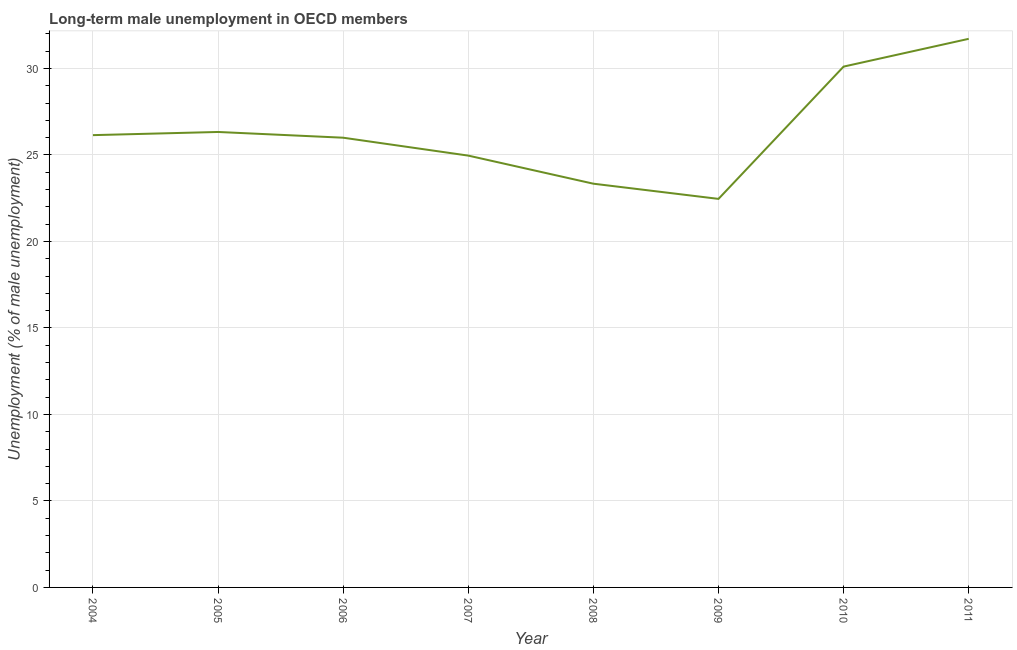What is the long-term male unemployment in 2004?
Offer a terse response. 26.15. Across all years, what is the maximum long-term male unemployment?
Give a very brief answer. 31.72. Across all years, what is the minimum long-term male unemployment?
Provide a short and direct response. 22.46. In which year was the long-term male unemployment minimum?
Offer a terse response. 2009. What is the sum of the long-term male unemployment?
Keep it short and to the point. 211.07. What is the difference between the long-term male unemployment in 2006 and 2011?
Give a very brief answer. -5.72. What is the average long-term male unemployment per year?
Offer a very short reply. 26.38. What is the median long-term male unemployment?
Give a very brief answer. 26.07. Do a majority of the years between 2006 and 2007 (inclusive) have long-term male unemployment greater than 9 %?
Ensure brevity in your answer.  Yes. What is the ratio of the long-term male unemployment in 2006 to that in 2011?
Provide a short and direct response. 0.82. Is the difference between the long-term male unemployment in 2004 and 2009 greater than the difference between any two years?
Make the answer very short. No. What is the difference between the highest and the second highest long-term male unemployment?
Keep it short and to the point. 1.61. What is the difference between the highest and the lowest long-term male unemployment?
Offer a very short reply. 9.25. Does the long-term male unemployment monotonically increase over the years?
Provide a succinct answer. No. How many lines are there?
Your answer should be compact. 1. What is the difference between two consecutive major ticks on the Y-axis?
Your response must be concise. 5. Does the graph contain any zero values?
Ensure brevity in your answer.  No. Does the graph contain grids?
Your response must be concise. Yes. What is the title of the graph?
Make the answer very short. Long-term male unemployment in OECD members. What is the label or title of the X-axis?
Provide a succinct answer. Year. What is the label or title of the Y-axis?
Keep it short and to the point. Unemployment (% of male unemployment). What is the Unemployment (% of male unemployment) in 2004?
Provide a succinct answer. 26.15. What is the Unemployment (% of male unemployment) in 2005?
Ensure brevity in your answer.  26.33. What is the Unemployment (% of male unemployment) of 2006?
Ensure brevity in your answer.  26. What is the Unemployment (% of male unemployment) of 2007?
Provide a succinct answer. 24.96. What is the Unemployment (% of male unemployment) in 2008?
Make the answer very short. 23.34. What is the Unemployment (% of male unemployment) in 2009?
Give a very brief answer. 22.46. What is the Unemployment (% of male unemployment) of 2010?
Your response must be concise. 30.11. What is the Unemployment (% of male unemployment) in 2011?
Your answer should be very brief. 31.72. What is the difference between the Unemployment (% of male unemployment) in 2004 and 2005?
Make the answer very short. -0.18. What is the difference between the Unemployment (% of male unemployment) in 2004 and 2006?
Your answer should be compact. 0.15. What is the difference between the Unemployment (% of male unemployment) in 2004 and 2007?
Your answer should be very brief. 1.18. What is the difference between the Unemployment (% of male unemployment) in 2004 and 2008?
Provide a short and direct response. 2.81. What is the difference between the Unemployment (% of male unemployment) in 2004 and 2009?
Your answer should be very brief. 3.69. What is the difference between the Unemployment (% of male unemployment) in 2004 and 2010?
Offer a very short reply. -3.96. What is the difference between the Unemployment (% of male unemployment) in 2004 and 2011?
Your answer should be very brief. -5.57. What is the difference between the Unemployment (% of male unemployment) in 2005 and 2006?
Your answer should be very brief. 0.33. What is the difference between the Unemployment (% of male unemployment) in 2005 and 2007?
Ensure brevity in your answer.  1.37. What is the difference between the Unemployment (% of male unemployment) in 2005 and 2008?
Give a very brief answer. 2.99. What is the difference between the Unemployment (% of male unemployment) in 2005 and 2009?
Make the answer very short. 3.87. What is the difference between the Unemployment (% of male unemployment) in 2005 and 2010?
Ensure brevity in your answer.  -3.78. What is the difference between the Unemployment (% of male unemployment) in 2005 and 2011?
Give a very brief answer. -5.38. What is the difference between the Unemployment (% of male unemployment) in 2006 and 2007?
Make the answer very short. 1.04. What is the difference between the Unemployment (% of male unemployment) in 2006 and 2008?
Give a very brief answer. 2.66. What is the difference between the Unemployment (% of male unemployment) in 2006 and 2009?
Offer a terse response. 3.54. What is the difference between the Unemployment (% of male unemployment) in 2006 and 2010?
Make the answer very short. -4.11. What is the difference between the Unemployment (% of male unemployment) in 2006 and 2011?
Ensure brevity in your answer.  -5.72. What is the difference between the Unemployment (% of male unemployment) in 2007 and 2008?
Your response must be concise. 1.62. What is the difference between the Unemployment (% of male unemployment) in 2007 and 2009?
Your answer should be very brief. 2.5. What is the difference between the Unemployment (% of male unemployment) in 2007 and 2010?
Provide a succinct answer. -5.15. What is the difference between the Unemployment (% of male unemployment) in 2007 and 2011?
Provide a short and direct response. -6.75. What is the difference between the Unemployment (% of male unemployment) in 2008 and 2009?
Give a very brief answer. 0.88. What is the difference between the Unemployment (% of male unemployment) in 2008 and 2010?
Give a very brief answer. -6.77. What is the difference between the Unemployment (% of male unemployment) in 2008 and 2011?
Your answer should be very brief. -8.38. What is the difference between the Unemployment (% of male unemployment) in 2009 and 2010?
Your response must be concise. -7.65. What is the difference between the Unemployment (% of male unemployment) in 2009 and 2011?
Make the answer very short. -9.25. What is the difference between the Unemployment (% of male unemployment) in 2010 and 2011?
Make the answer very short. -1.61. What is the ratio of the Unemployment (% of male unemployment) in 2004 to that in 2006?
Give a very brief answer. 1.01. What is the ratio of the Unemployment (% of male unemployment) in 2004 to that in 2007?
Your answer should be compact. 1.05. What is the ratio of the Unemployment (% of male unemployment) in 2004 to that in 2008?
Make the answer very short. 1.12. What is the ratio of the Unemployment (% of male unemployment) in 2004 to that in 2009?
Provide a short and direct response. 1.16. What is the ratio of the Unemployment (% of male unemployment) in 2004 to that in 2010?
Give a very brief answer. 0.87. What is the ratio of the Unemployment (% of male unemployment) in 2004 to that in 2011?
Give a very brief answer. 0.82. What is the ratio of the Unemployment (% of male unemployment) in 2005 to that in 2007?
Your response must be concise. 1.05. What is the ratio of the Unemployment (% of male unemployment) in 2005 to that in 2008?
Keep it short and to the point. 1.13. What is the ratio of the Unemployment (% of male unemployment) in 2005 to that in 2009?
Provide a short and direct response. 1.17. What is the ratio of the Unemployment (% of male unemployment) in 2005 to that in 2010?
Your answer should be very brief. 0.87. What is the ratio of the Unemployment (% of male unemployment) in 2005 to that in 2011?
Your response must be concise. 0.83. What is the ratio of the Unemployment (% of male unemployment) in 2006 to that in 2007?
Provide a short and direct response. 1.04. What is the ratio of the Unemployment (% of male unemployment) in 2006 to that in 2008?
Your response must be concise. 1.11. What is the ratio of the Unemployment (% of male unemployment) in 2006 to that in 2009?
Your answer should be very brief. 1.16. What is the ratio of the Unemployment (% of male unemployment) in 2006 to that in 2010?
Give a very brief answer. 0.86. What is the ratio of the Unemployment (% of male unemployment) in 2006 to that in 2011?
Keep it short and to the point. 0.82. What is the ratio of the Unemployment (% of male unemployment) in 2007 to that in 2008?
Make the answer very short. 1.07. What is the ratio of the Unemployment (% of male unemployment) in 2007 to that in 2009?
Provide a short and direct response. 1.11. What is the ratio of the Unemployment (% of male unemployment) in 2007 to that in 2010?
Make the answer very short. 0.83. What is the ratio of the Unemployment (% of male unemployment) in 2007 to that in 2011?
Your answer should be very brief. 0.79. What is the ratio of the Unemployment (% of male unemployment) in 2008 to that in 2009?
Your answer should be very brief. 1.04. What is the ratio of the Unemployment (% of male unemployment) in 2008 to that in 2010?
Your response must be concise. 0.78. What is the ratio of the Unemployment (% of male unemployment) in 2008 to that in 2011?
Offer a very short reply. 0.74. What is the ratio of the Unemployment (% of male unemployment) in 2009 to that in 2010?
Provide a short and direct response. 0.75. What is the ratio of the Unemployment (% of male unemployment) in 2009 to that in 2011?
Your answer should be very brief. 0.71. What is the ratio of the Unemployment (% of male unemployment) in 2010 to that in 2011?
Make the answer very short. 0.95. 